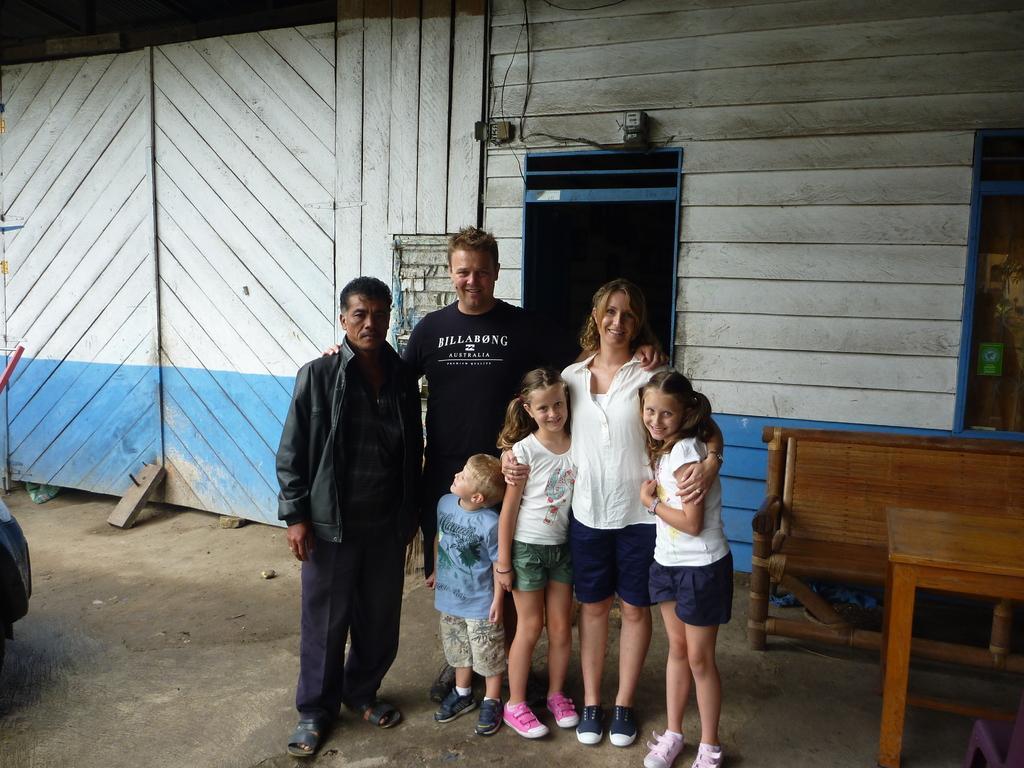Please provide a concise description of this image. In the foreground I can see six persons are standing on the floor, table and a bench. In the background I can see a wooden wall. This image is taken may be during a day. 